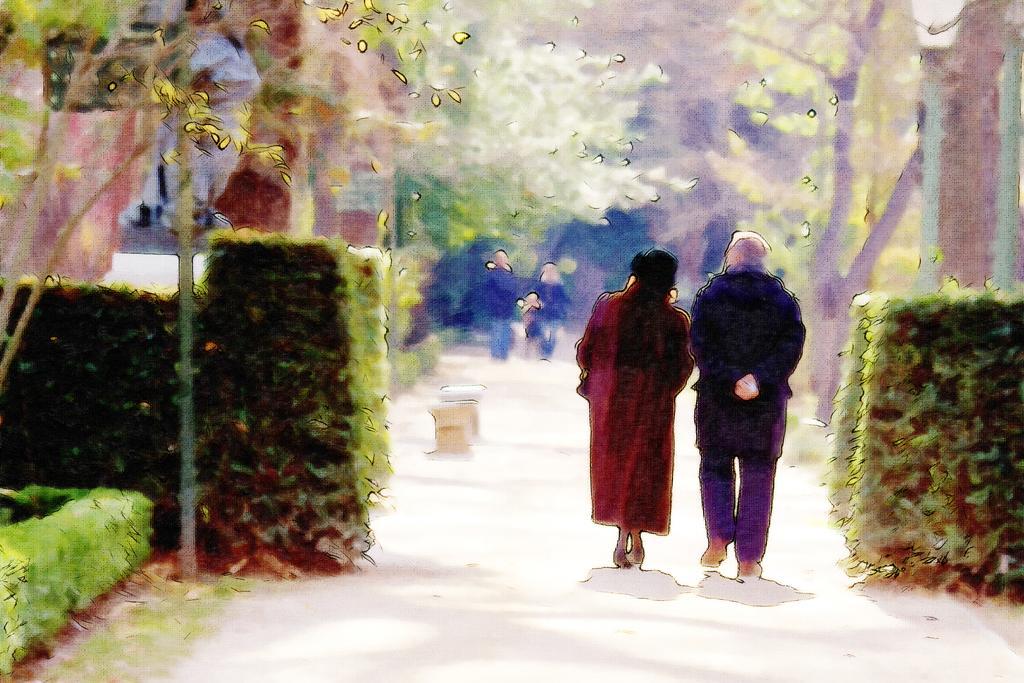Please provide a concise description of this image. This is a sketch in which we can see two persons are walking, on the either side of the image we can see shrubs. In the background, we can see two persons are walking and we can see trees. 